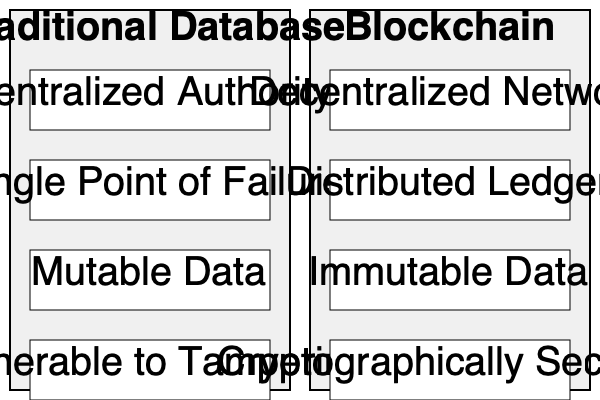Based on the side-by-side comparison of traditional database security and blockchain security, which key feature of blockchain technology makes it particularly suitable for secure patient data management in healthcare institutions? To answer this question, let's analyze the key differences between traditional database security and blockchain security as shown in the diagram:

1. Centralization vs. Decentralization:
   - Traditional databases rely on a centralized authority, while blockchain uses a decentralized network.
   - This decentralization reduces the risk of a single point of failure.

2. Data Storage:
   - Traditional databases have a single point of failure, whereas blockchain uses a distributed ledger.
   - Distributed ledgers enhance data redundancy and availability.

3. Data Mutability:
   - Traditional databases contain mutable data, which can be altered.
   - Blockchain contains immutable data, meaning once recorded, it cannot be easily changed.

4. Data Security:
   - Traditional databases are more vulnerable to tampering.
   - Blockchain is cryptographically secured, making it extremely difficult to alter records without detection.

For secure patient data management in healthcare institutions, the most critical feature is data immutability. This ensures that patient records, once entered, cannot be altered or tampered with, maintaining the integrity and trustworthiness of the medical history. The immutability of blockchain records provides an auditable trail of all changes, which is crucial for maintaining accurate and reliable patient data in healthcare settings.
Answer: Data immutability 